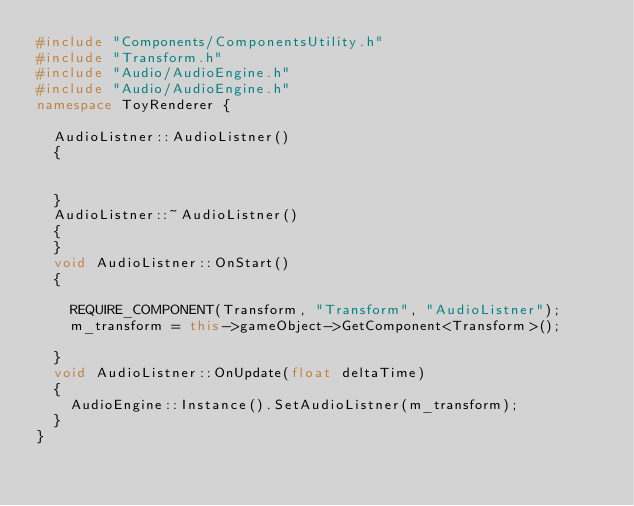Convert code to text. <code><loc_0><loc_0><loc_500><loc_500><_C++_>#include "Components/ComponentsUtility.h"
#include "Transform.h"
#include "Audio/AudioEngine.h"
#include "Audio/AudioEngine.h"
namespace ToyRenderer {

	AudioListner::AudioListner()
	{
		

	}
	AudioListner::~AudioListner()
	{
	}
	void AudioListner::OnStart()
	{
		
		REQUIRE_COMPONENT(Transform, "Transform", "AudioListner");
		m_transform = this->gameObject->GetComponent<Transform>();

	}
	void AudioListner::OnUpdate(float deltaTime)
	{
		AudioEngine::Instance().SetAudioListner(m_transform);
	}
}
</code> 